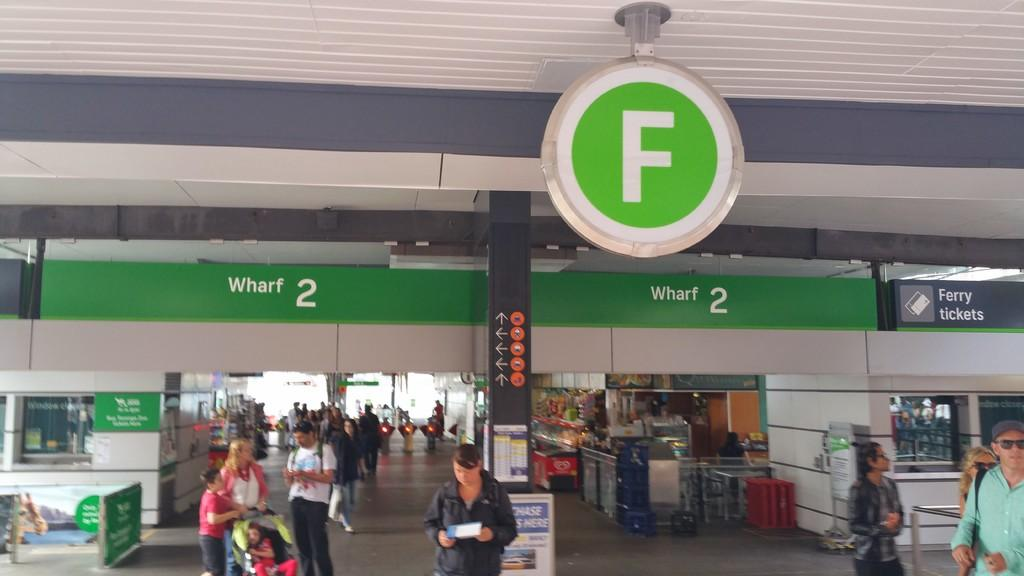<image>
Create a compact narrative representing the image presented. People walking around area "F" of a metro transit station 